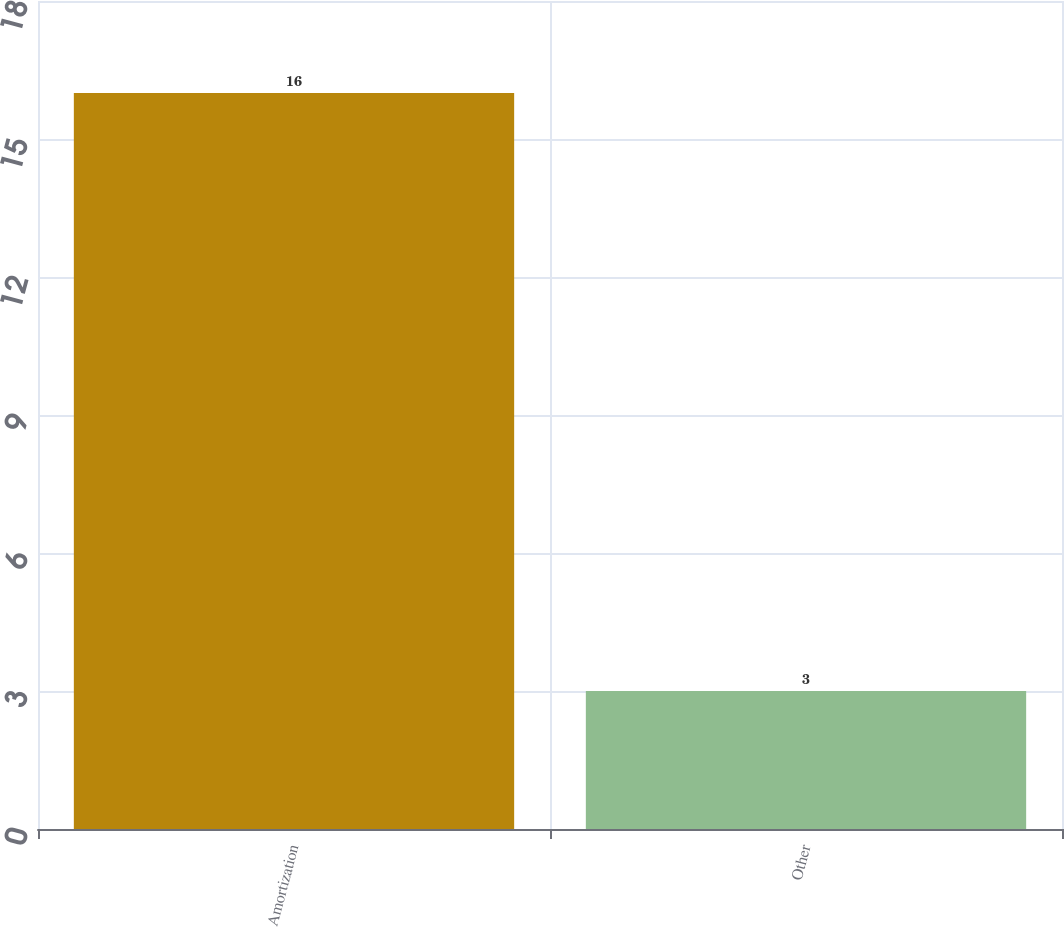Convert chart. <chart><loc_0><loc_0><loc_500><loc_500><bar_chart><fcel>Amortization<fcel>Other<nl><fcel>16<fcel>3<nl></chart> 